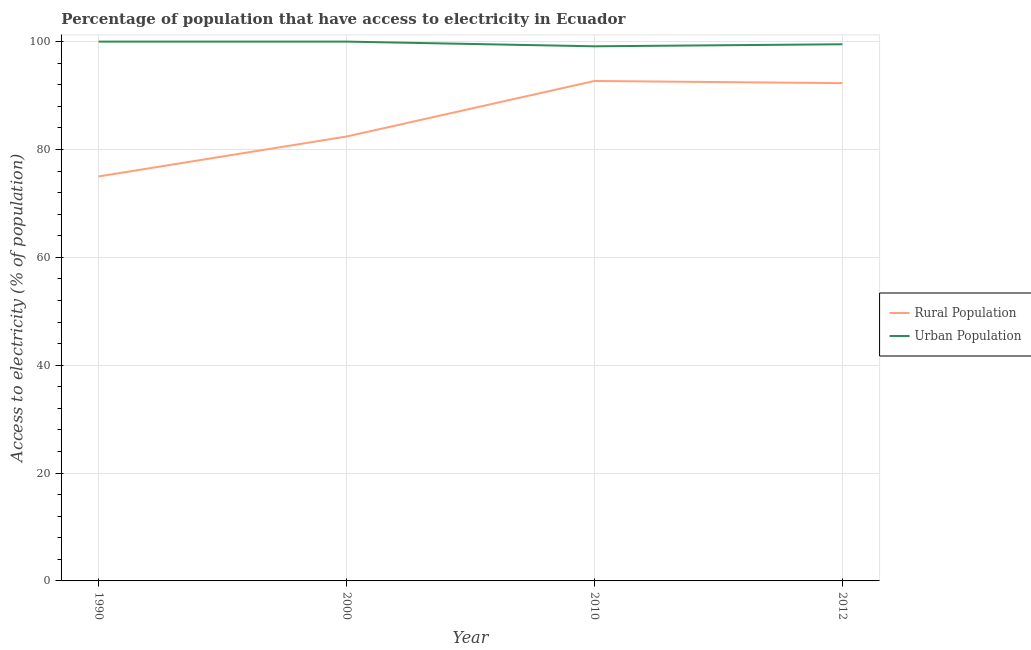How many different coloured lines are there?
Your answer should be very brief. 2. What is the percentage of rural population having access to electricity in 2012?
Your answer should be compact. 92.3. Across all years, what is the maximum percentage of rural population having access to electricity?
Offer a terse response. 92.7. Across all years, what is the minimum percentage of rural population having access to electricity?
Your answer should be very brief. 75. In which year was the percentage of rural population having access to electricity maximum?
Provide a succinct answer. 2010. In which year was the percentage of rural population having access to electricity minimum?
Keep it short and to the point. 1990. What is the total percentage of rural population having access to electricity in the graph?
Provide a succinct answer. 342.4. What is the difference between the percentage of urban population having access to electricity in 2000 and that in 2010?
Offer a very short reply. 0.87. What is the difference between the percentage of urban population having access to electricity in 2010 and the percentage of rural population having access to electricity in 2000?
Provide a short and direct response. 16.73. What is the average percentage of urban population having access to electricity per year?
Your response must be concise. 99.66. In the year 1990, what is the difference between the percentage of rural population having access to electricity and percentage of urban population having access to electricity?
Your response must be concise. -25. In how many years, is the percentage of rural population having access to electricity greater than 36 %?
Ensure brevity in your answer.  4. What is the ratio of the percentage of urban population having access to electricity in 2010 to that in 2012?
Keep it short and to the point. 1. Is the percentage of rural population having access to electricity in 1990 less than that in 2012?
Give a very brief answer. Yes. Is the difference between the percentage of urban population having access to electricity in 1990 and 2000 greater than the difference between the percentage of rural population having access to electricity in 1990 and 2000?
Offer a very short reply. Yes. What is the difference between the highest and the second highest percentage of rural population having access to electricity?
Keep it short and to the point. 0.4. What is the difference between the highest and the lowest percentage of rural population having access to electricity?
Offer a very short reply. 17.7. In how many years, is the percentage of rural population having access to electricity greater than the average percentage of rural population having access to electricity taken over all years?
Offer a terse response. 2. Is the sum of the percentage of urban population having access to electricity in 1990 and 2012 greater than the maximum percentage of rural population having access to electricity across all years?
Ensure brevity in your answer.  Yes. Does the percentage of rural population having access to electricity monotonically increase over the years?
Provide a succinct answer. No. Is the percentage of rural population having access to electricity strictly greater than the percentage of urban population having access to electricity over the years?
Your answer should be very brief. No. How many lines are there?
Make the answer very short. 2. How many years are there in the graph?
Offer a terse response. 4. What is the difference between two consecutive major ticks on the Y-axis?
Give a very brief answer. 20. Does the graph contain any zero values?
Provide a succinct answer. No. Does the graph contain grids?
Keep it short and to the point. Yes. How many legend labels are there?
Give a very brief answer. 2. How are the legend labels stacked?
Ensure brevity in your answer.  Vertical. What is the title of the graph?
Provide a short and direct response. Percentage of population that have access to electricity in Ecuador. Does "Chemicals" appear as one of the legend labels in the graph?
Ensure brevity in your answer.  No. What is the label or title of the X-axis?
Your response must be concise. Year. What is the label or title of the Y-axis?
Offer a very short reply. Access to electricity (% of population). What is the Access to electricity (% of population) of Rural Population in 2000?
Give a very brief answer. 82.4. What is the Access to electricity (% of population) of Urban Population in 2000?
Your answer should be very brief. 100. What is the Access to electricity (% of population) in Rural Population in 2010?
Make the answer very short. 92.7. What is the Access to electricity (% of population) in Urban Population in 2010?
Your answer should be compact. 99.13. What is the Access to electricity (% of population) in Rural Population in 2012?
Provide a succinct answer. 92.3. What is the Access to electricity (% of population) of Urban Population in 2012?
Give a very brief answer. 99.51. Across all years, what is the maximum Access to electricity (% of population) of Rural Population?
Provide a succinct answer. 92.7. Across all years, what is the maximum Access to electricity (% of population) of Urban Population?
Provide a short and direct response. 100. Across all years, what is the minimum Access to electricity (% of population) of Rural Population?
Provide a short and direct response. 75. Across all years, what is the minimum Access to electricity (% of population) of Urban Population?
Make the answer very short. 99.13. What is the total Access to electricity (% of population) in Rural Population in the graph?
Offer a terse response. 342.4. What is the total Access to electricity (% of population) of Urban Population in the graph?
Offer a terse response. 398.64. What is the difference between the Access to electricity (% of population) in Rural Population in 1990 and that in 2000?
Offer a terse response. -7.4. What is the difference between the Access to electricity (% of population) in Urban Population in 1990 and that in 2000?
Your answer should be compact. 0. What is the difference between the Access to electricity (% of population) in Rural Population in 1990 and that in 2010?
Give a very brief answer. -17.7. What is the difference between the Access to electricity (% of population) in Urban Population in 1990 and that in 2010?
Ensure brevity in your answer.  0.87. What is the difference between the Access to electricity (% of population) in Rural Population in 1990 and that in 2012?
Make the answer very short. -17.3. What is the difference between the Access to electricity (% of population) of Urban Population in 1990 and that in 2012?
Ensure brevity in your answer.  0.49. What is the difference between the Access to electricity (% of population) in Urban Population in 2000 and that in 2010?
Provide a succinct answer. 0.87. What is the difference between the Access to electricity (% of population) in Urban Population in 2000 and that in 2012?
Your answer should be very brief. 0.49. What is the difference between the Access to electricity (% of population) in Urban Population in 2010 and that in 2012?
Provide a short and direct response. -0.38. What is the difference between the Access to electricity (% of population) of Rural Population in 1990 and the Access to electricity (% of population) of Urban Population in 2010?
Provide a succinct answer. -24.13. What is the difference between the Access to electricity (% of population) in Rural Population in 1990 and the Access to electricity (% of population) in Urban Population in 2012?
Your response must be concise. -24.51. What is the difference between the Access to electricity (% of population) of Rural Population in 2000 and the Access to electricity (% of population) of Urban Population in 2010?
Keep it short and to the point. -16.73. What is the difference between the Access to electricity (% of population) in Rural Population in 2000 and the Access to electricity (% of population) in Urban Population in 2012?
Offer a terse response. -17.11. What is the difference between the Access to electricity (% of population) of Rural Population in 2010 and the Access to electricity (% of population) of Urban Population in 2012?
Keep it short and to the point. -6.81. What is the average Access to electricity (% of population) of Rural Population per year?
Offer a very short reply. 85.6. What is the average Access to electricity (% of population) of Urban Population per year?
Make the answer very short. 99.66. In the year 1990, what is the difference between the Access to electricity (% of population) of Rural Population and Access to electricity (% of population) of Urban Population?
Your answer should be compact. -25. In the year 2000, what is the difference between the Access to electricity (% of population) of Rural Population and Access to electricity (% of population) of Urban Population?
Keep it short and to the point. -17.6. In the year 2010, what is the difference between the Access to electricity (% of population) of Rural Population and Access to electricity (% of population) of Urban Population?
Provide a short and direct response. -6.43. In the year 2012, what is the difference between the Access to electricity (% of population) in Rural Population and Access to electricity (% of population) in Urban Population?
Ensure brevity in your answer.  -7.21. What is the ratio of the Access to electricity (% of population) of Rural Population in 1990 to that in 2000?
Offer a very short reply. 0.91. What is the ratio of the Access to electricity (% of population) in Urban Population in 1990 to that in 2000?
Your response must be concise. 1. What is the ratio of the Access to electricity (% of population) of Rural Population in 1990 to that in 2010?
Offer a terse response. 0.81. What is the ratio of the Access to electricity (% of population) of Urban Population in 1990 to that in 2010?
Offer a terse response. 1.01. What is the ratio of the Access to electricity (% of population) of Rural Population in 1990 to that in 2012?
Offer a very short reply. 0.81. What is the ratio of the Access to electricity (% of population) in Urban Population in 1990 to that in 2012?
Keep it short and to the point. 1. What is the ratio of the Access to electricity (% of population) of Rural Population in 2000 to that in 2010?
Your answer should be very brief. 0.89. What is the ratio of the Access to electricity (% of population) in Urban Population in 2000 to that in 2010?
Your answer should be compact. 1.01. What is the ratio of the Access to electricity (% of population) in Rural Population in 2000 to that in 2012?
Offer a very short reply. 0.89. What is the ratio of the Access to electricity (% of population) of Urban Population in 2000 to that in 2012?
Provide a short and direct response. 1. What is the difference between the highest and the second highest Access to electricity (% of population) of Rural Population?
Your answer should be compact. 0.4. What is the difference between the highest and the lowest Access to electricity (% of population) in Urban Population?
Offer a terse response. 0.87. 